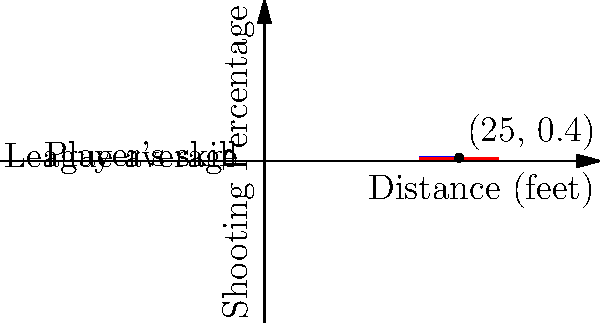As a video game developer working on a basketball simulation, you're implementing a feature to calculate the probability of making a three-point shot. The blue line represents a player's shooting percentage based on distance, while the red line shows the league average. If a player attempts a three-pointer from 25 feet, and their shooting percentage at this distance is 40%, what's the probability of making the shot if they're 33% more likely to score than the league average? Let's approach this step-by-step:

1) From the graph, we can see that at 25 feet:
   - The player's shooting percentage is 40% or 0.4
   - The league average is 30% or 0.3

2) We're told the player is 33% more likely to score than the league average. To calculate this:
   - Convert 33% to a decimal: 33% = 0.33
   - Multiply the league average by (1 + 0.33):
     $0.3 * (1 + 0.33) = 0.3 * 1.33 = 0.399$

3) The player's actual percentage (0.4) is very close to this calculated value (0.399), confirming that they are indeed about 33% more likely to score than the league average.

4) Therefore, the probability of making the shot is simply the player's shooting percentage at 25 feet, which is 40% or 0.4.
Answer: $0.4$ or $40\%$ 